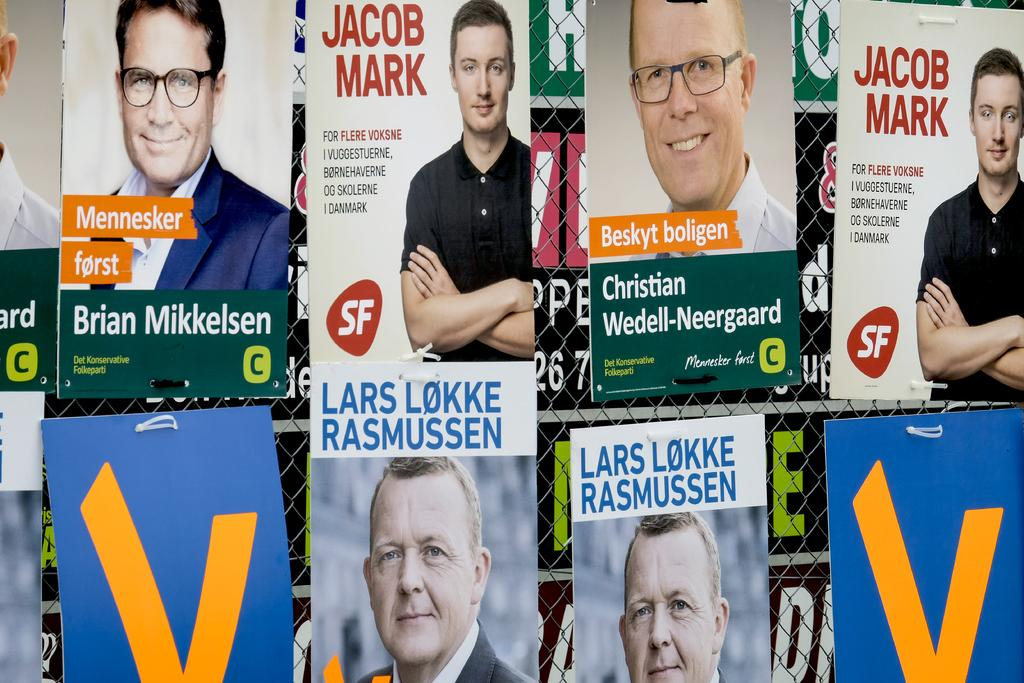What can be seen on the boards in the image? The boards have text and images in the image. What is located in the center of the image? There is a fence in the center of the image. What is written on the banners in the background of the image? The banners have text in the background of the image. Can you see a coil on the fence in the image? There is no coil present on the fence in the image. What type of note is attached to the banners in the background? There are no notes attached to the banners in the background; only text is visible. 